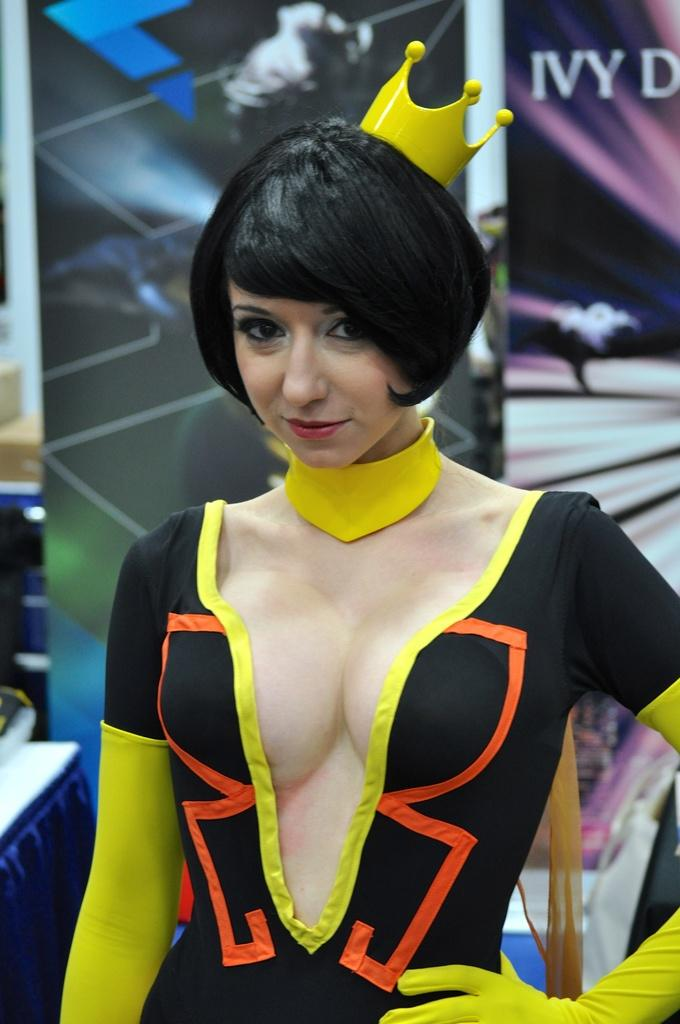<image>
Write a terse but informative summary of the picture. a lady that is wearing a costume with the word Ivy behind her in the distance 